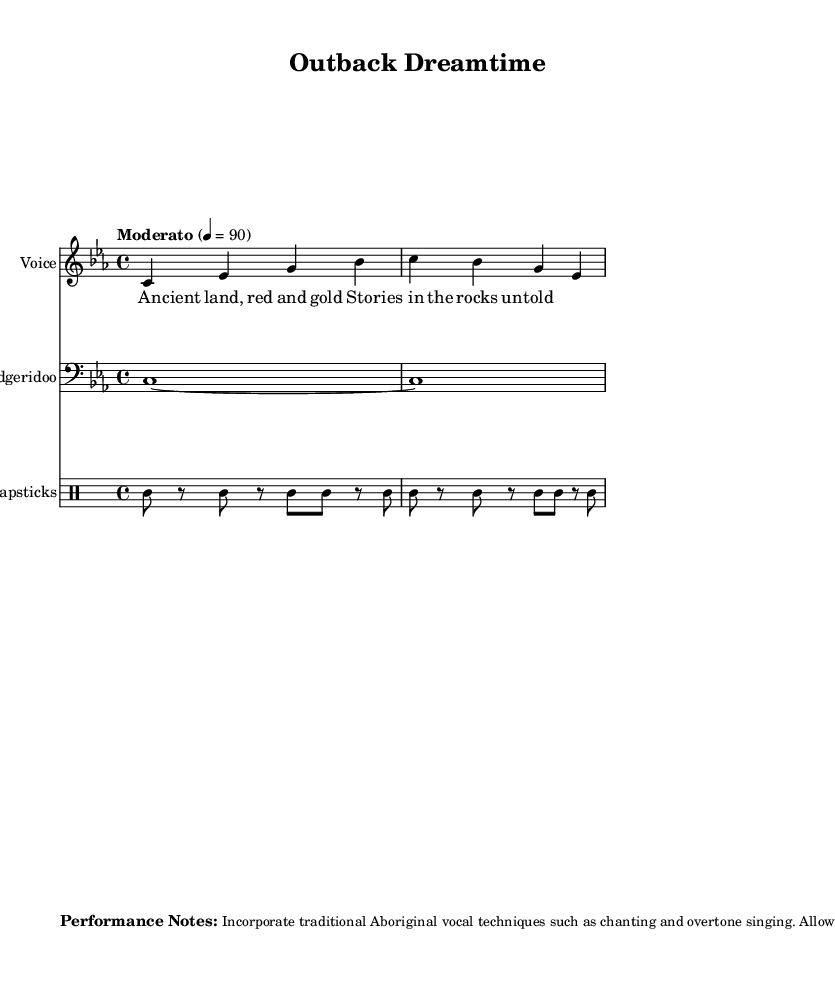What is the key signature of this music? The key signature is C minor, which features three flat symbols (B♭, E♭, A♭) indicating that each of these notes should be played flat.
Answer: C minor What is the time signature of this piece? The time signature shown is 4/4, indicating that there are four beats in each measure and that the quarter note receives one beat.
Answer: 4/4 What is the tempo marking for the piece? The tempo marking is set at Moderato, defined by the metronome mark of 90 beats per minute, indicating a moderate pace for the performance.
Answer: Moderato How many measures are there in the melody section? By counting the number of vertical lines in the melody part, which each represent the end of a measure, we find there are two measures in the melody section.
Answer: 2 What instruments are included in this score? The score includes three instruments: Voice, Didgeridoo, and Clapsticks. Each of these instruments has its own staff for notation.
Answer: Voice, Didgeridoo, Clapsticks What cultural elements are suggested in the performance notes? The performance notes encourage the use of traditional Aboriginal techniques such as chanting and overtone singing, promoting cultural authenticity in the performance.
Answer: Chanting, overtone singing 